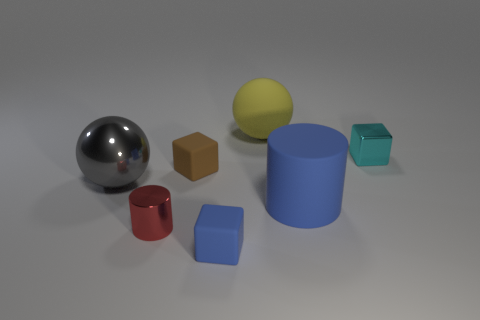Add 1 yellow objects. How many objects exist? 8 Subtract all cylinders. How many objects are left? 5 Subtract 1 blue cylinders. How many objects are left? 6 Subtract all tiny red shiny cylinders. Subtract all tiny yellow metallic blocks. How many objects are left? 6 Add 7 tiny cyan metallic objects. How many tiny cyan metallic objects are left? 8 Add 1 big green spheres. How many big green spheres exist? 1 